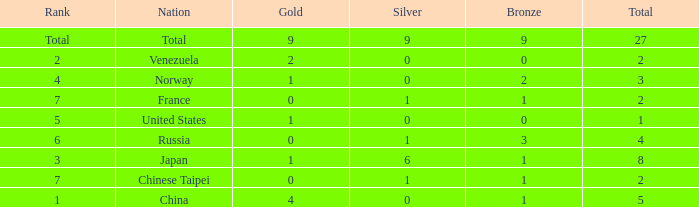What is the total number of Bronze when gold is more than 1 and nation is total? 1.0. 